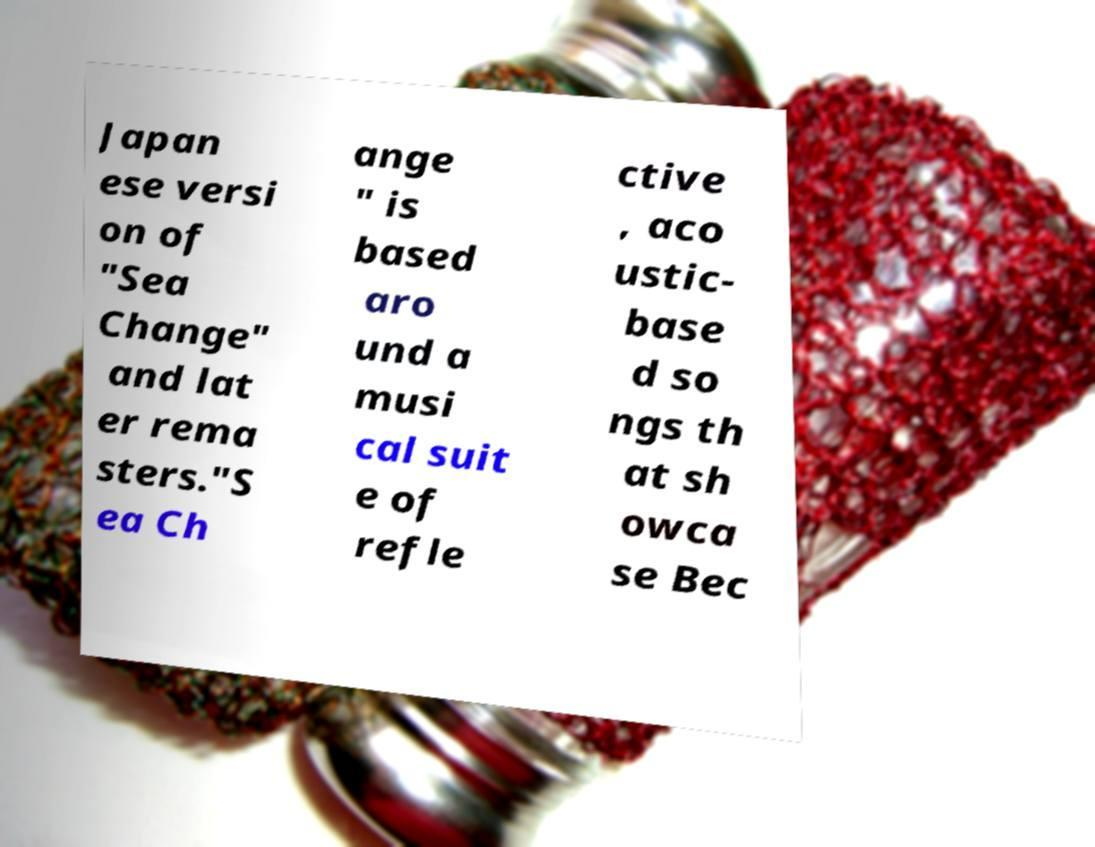I need the written content from this picture converted into text. Can you do that? Japan ese versi on of "Sea Change" and lat er rema sters."S ea Ch ange " is based aro und a musi cal suit e of refle ctive , aco ustic- base d so ngs th at sh owca se Bec 